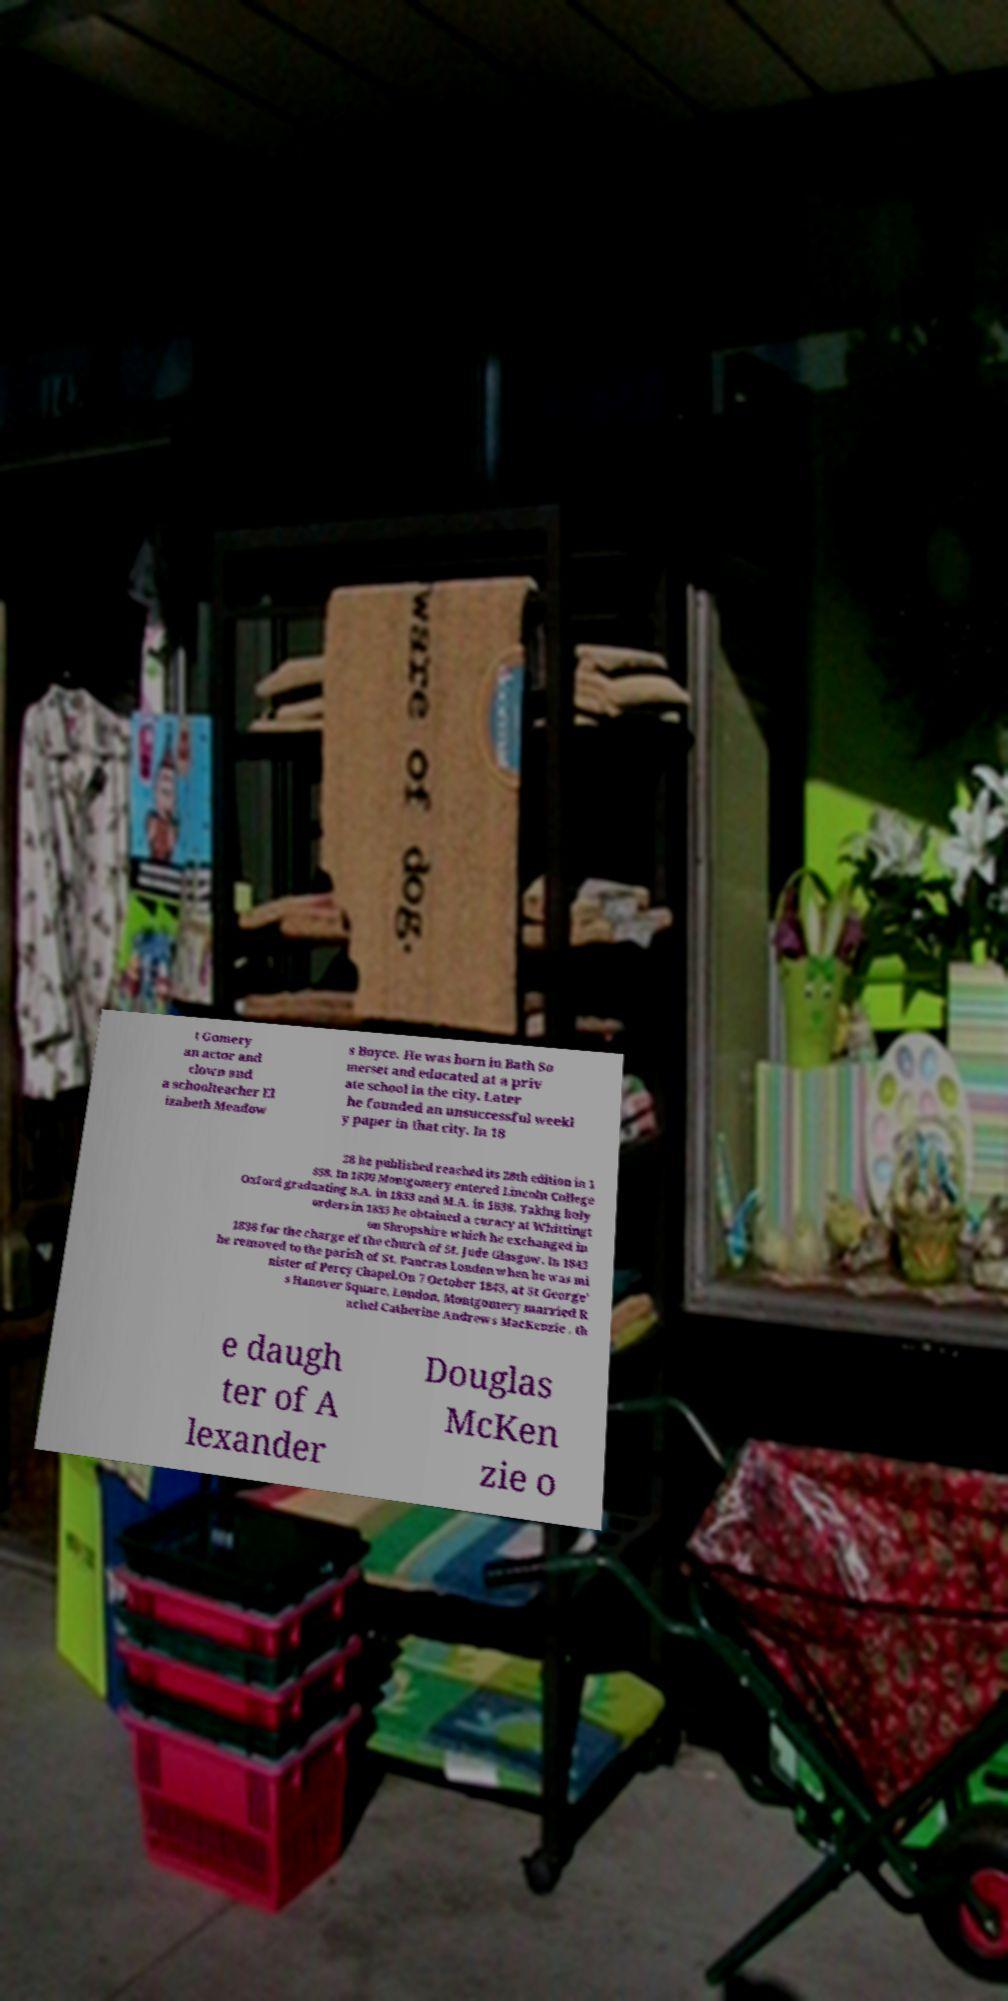I need the written content from this picture converted into text. Can you do that? t Gomery an actor and clown and a schoolteacher El izabeth Meadow s Boyce. He was born in Bath So merset and educated at a priv ate school in the city. Later he founded an unsuccessful weekl y paper in that city. In 18 28 he published reached its 28th edition in 1 858. In 1830 Montgomery entered Lincoln College Oxford graduating B.A. in 1833 and M.A. in 1838. Taking holy orders in 1835 he obtained a curacy at Whittingt on Shropshire which he exchanged in 1836 for the charge of the church of St. Jude Glasgow. In 1843 he removed to the parish of St. Pancras London when he was mi nister of Percy Chapel.On 7 October 1843, at St George' s Hanover Square, London, Montgomery married R achel Catherine Andrews MacKenzie , th e daugh ter of A lexander Douglas McKen zie o 